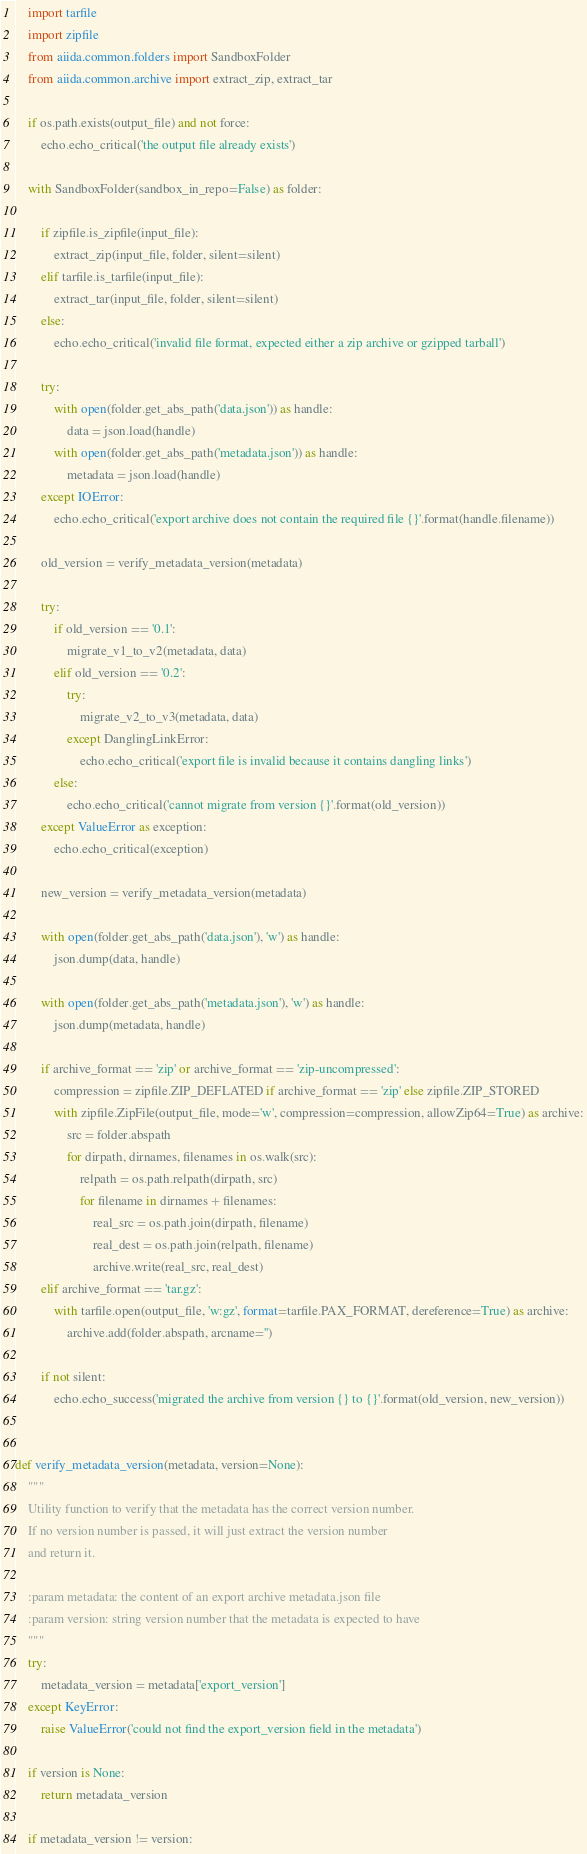<code> <loc_0><loc_0><loc_500><loc_500><_Python_>    import tarfile
    import zipfile
    from aiida.common.folders import SandboxFolder
    from aiida.common.archive import extract_zip, extract_tar

    if os.path.exists(output_file) and not force:
        echo.echo_critical('the output file already exists')

    with SandboxFolder(sandbox_in_repo=False) as folder:

        if zipfile.is_zipfile(input_file):
            extract_zip(input_file, folder, silent=silent)
        elif tarfile.is_tarfile(input_file):
            extract_tar(input_file, folder, silent=silent)
        else:
            echo.echo_critical('invalid file format, expected either a zip archive or gzipped tarball')

        try:
            with open(folder.get_abs_path('data.json')) as handle:
                data = json.load(handle)
            with open(folder.get_abs_path('metadata.json')) as handle:
                metadata = json.load(handle)
        except IOError:
            echo.echo_critical('export archive does not contain the required file {}'.format(handle.filename))

        old_version = verify_metadata_version(metadata)

        try:
            if old_version == '0.1':
                migrate_v1_to_v2(metadata, data)
            elif old_version == '0.2':
                try:
                    migrate_v2_to_v3(metadata, data)
                except DanglingLinkError:
                    echo.echo_critical('export file is invalid because it contains dangling links')
            else:
                echo.echo_critical('cannot migrate from version {}'.format(old_version))
        except ValueError as exception:
            echo.echo_critical(exception)

        new_version = verify_metadata_version(metadata)

        with open(folder.get_abs_path('data.json'), 'w') as handle:
            json.dump(data, handle)

        with open(folder.get_abs_path('metadata.json'), 'w') as handle:
            json.dump(metadata, handle)

        if archive_format == 'zip' or archive_format == 'zip-uncompressed':
            compression = zipfile.ZIP_DEFLATED if archive_format == 'zip' else zipfile.ZIP_STORED
            with zipfile.ZipFile(output_file, mode='w', compression=compression, allowZip64=True) as archive:
                src = folder.abspath
                for dirpath, dirnames, filenames in os.walk(src):
                    relpath = os.path.relpath(dirpath, src)
                    for filename in dirnames + filenames:
                        real_src = os.path.join(dirpath, filename)
                        real_dest = os.path.join(relpath, filename)
                        archive.write(real_src, real_dest)
        elif archive_format == 'tar.gz':
            with tarfile.open(output_file, 'w:gz', format=tarfile.PAX_FORMAT, dereference=True) as archive:
                archive.add(folder.abspath, arcname='')

        if not silent:
            echo.echo_success('migrated the archive from version {} to {}'.format(old_version, new_version))


def verify_metadata_version(metadata, version=None):
    """
    Utility function to verify that the metadata has the correct version number.
    If no version number is passed, it will just extract the version number
    and return it.

    :param metadata: the content of an export archive metadata.json file
    :param version: string version number that the metadata is expected to have
    """
    try:
        metadata_version = metadata['export_version']
    except KeyError:
        raise ValueError('could not find the export_version field in the metadata')

    if version is None:
        return metadata_version

    if metadata_version != version:</code> 